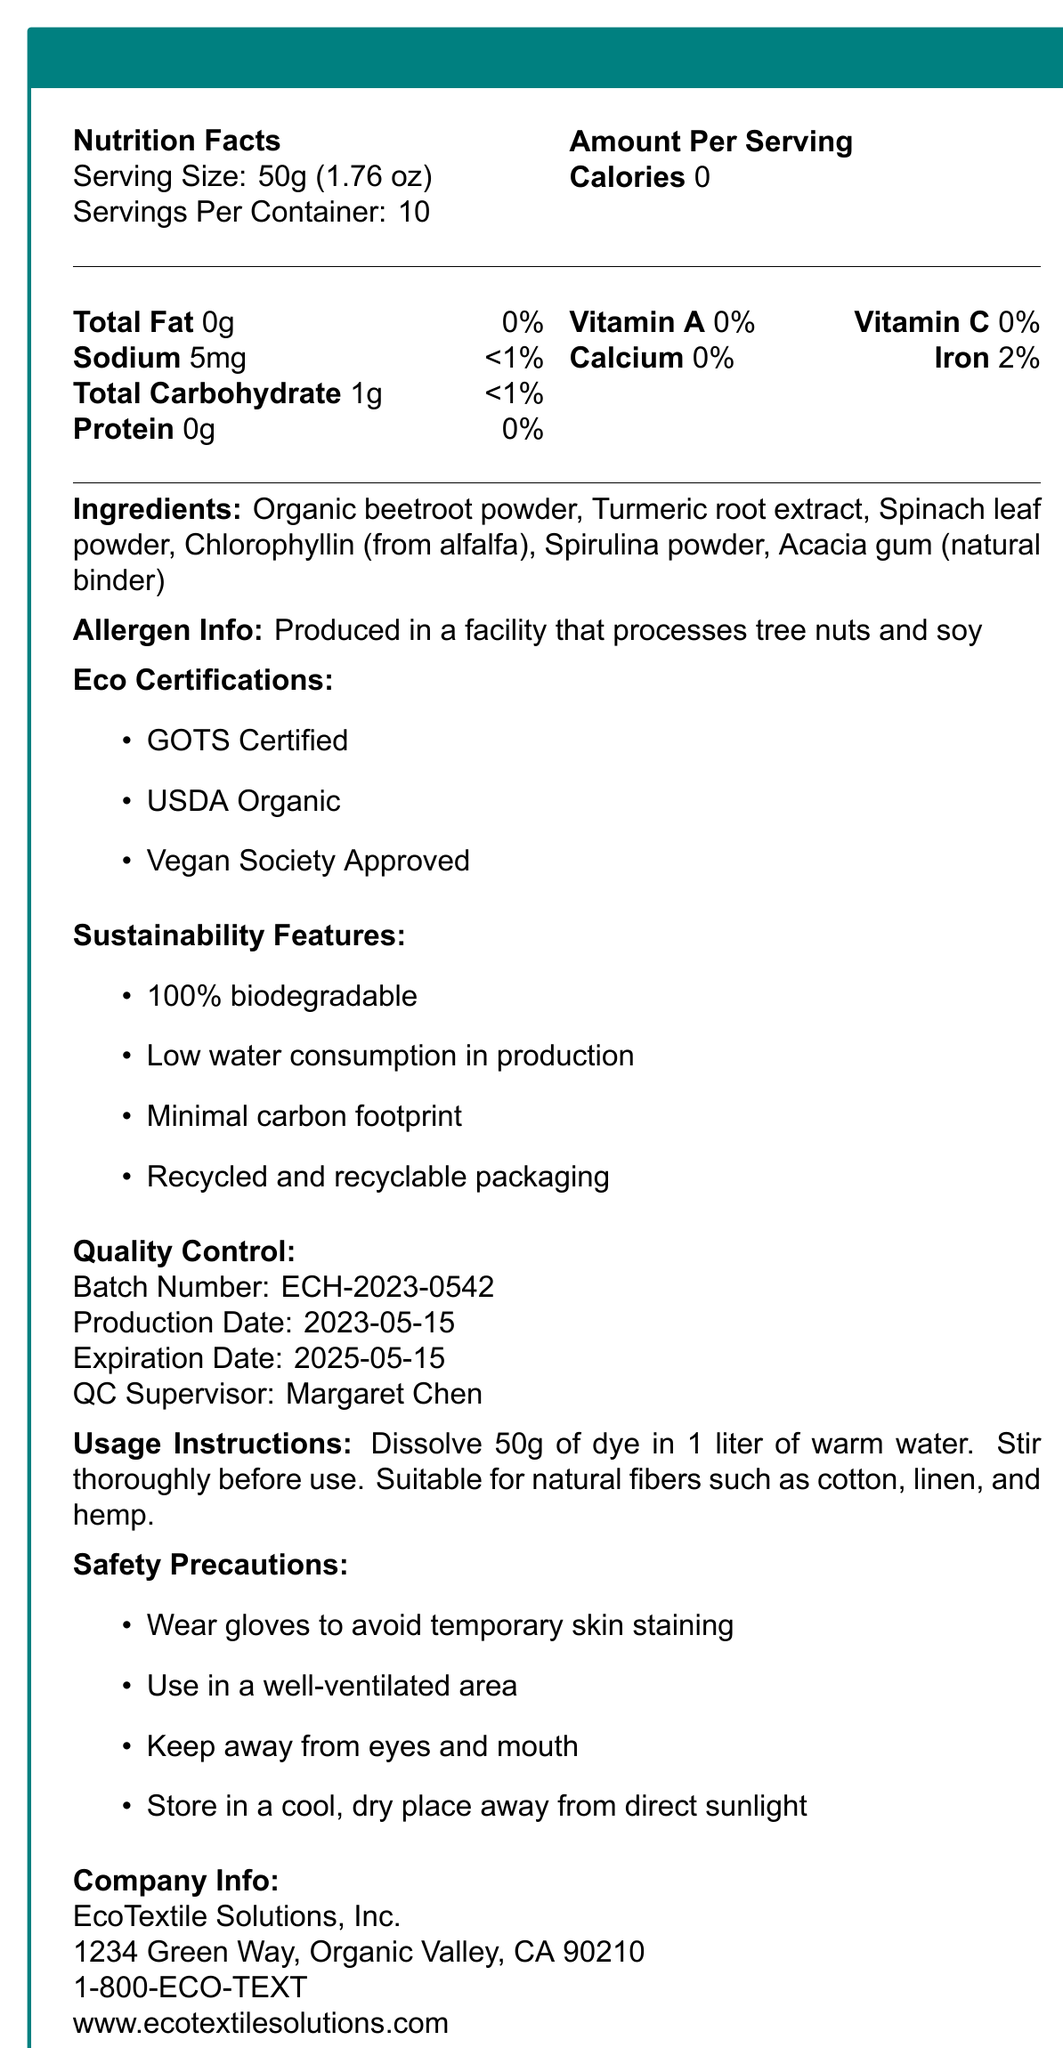what is the name of the product? The name of the product is clearly stated at the beginning of the document.
Answer: EcoHue Natural Fabric Dye what is the serving size for the product? The serving size is listed as 50g (1.76 oz) in the Nutrition Facts section.
Answer: 50g (1.76 oz) how many servings are there per container? The document specifies that there are 10 servings per container.
Answer: 10 what is the total fat content per serving? In the Nutrition Facts section, the total fat content per serving is listed as 0g.
Answer: 0g what are the main ingredients used in the dye? The main ingredients are listed under the Ingredients section.
Answer: Organic beetroot powder, Turmeric root extract, Spinach leaf powder, Chlorophyllin (from alfalfa), Spirulina powder, Acacia gum (natural binder) what is the sodium content per serving? The sodium content is listed as 5mg per serving in the Nutrition Facts section.
Answer: 5mg what allergens are present in the production facility? The allergen information states that the product is produced in a facility that processes tree nuts and soy.
Answer: Tree nuts and soy what is the batch number of the product? The batch number is listed in the Quality Control section.
Answer: ECH-2023-0542 what is the recommended method for using the dye? The usage instructions provide detailed steps for using the dye.
Answer: Dissolve 50g of dye in 1 liter of warm water. Stir thoroughly before use. Suitable for natural fibers such as cotton, linen, and hemp. where should the product be stored? The safety precautions advise storing the product in a cool, dry place away from direct sunlight.
Answer: In a cool, dry place away from direct sunlight how many calories does the product have per serving? The Nutrition Facts section lists the calorie content as 0 per serving.
Answer: 0 which eco-certifications does the product have? A. GOTS Certified B. USDA Organic C. Vegan Society Approved D. All of the above The product has all three certifications: GOTS Certified, USDA Organic, and Vegan Society Approved, as stated in the Eco Certifications section.
Answer: D what is the daily value percentage of iron per serving? A. 0% B. 2% C. 5% D. 10% The Nutrition Facts section shows the daily value percentage of iron per serving as 2%.
Answer: B is the product 100% biodegradable? The sustainability features list "100% biodegradable" as one of the features.
Answer: Yes does the product contain any artificial additives? The document emphasizes that the product is eco-friendly and plant-based, with no artificial additives listed in the ingredients.
Answer: No summarize the important information about the product in a few sentences. This summary encapsulates the primary information about the product, its ingredients, certifications, sustainability features, allergen info, and quality control notes.
Answer: The EcoHue Natural Fabric Dye is an eco-friendly, plant-based dye, free of artificial additives and allergens. It has several eco-certifications and sustainability features, including being 100% biodegradable. The product contains organic ingredients like beetroot powder and is produced in a facility that processes tree nuts and soy. Detailed usage instructions and safety precautions are provided, and the product is handled under strict quality control measures. what is the pH range of the product? The additional info section specifies that the pH range is 6.5-7.5.
Answer: 6.5-7.5 when is the expiration date of the product? The expiration date is listed in the Quality Control section.
Answer: 2025-05-15 who is the Quality Control Supervisor for this batch? The Quality Control section names Margaret Chen as the Quality Control Supervisor.
Answer: Margaret Chen what is the carbon footprint of the product's production process? While the document mentions minimal carbon footprint as a sustainability feature, it doesn't provide specific details on the carbon footprint.
Answer: Not enough information What are the light fastness and color fastness ratings of the product? The additional info section specifies the light fastness rating as 'Very Good (ISO 105-B02)' and the color fastness rating as 'Excellent (AATCC Test Method 61-2A)'.
Answer: Light Fastness: Very Good (ISO 105-B02), Color Fastness: Excellent (AATCC Test Method 61-2A) 